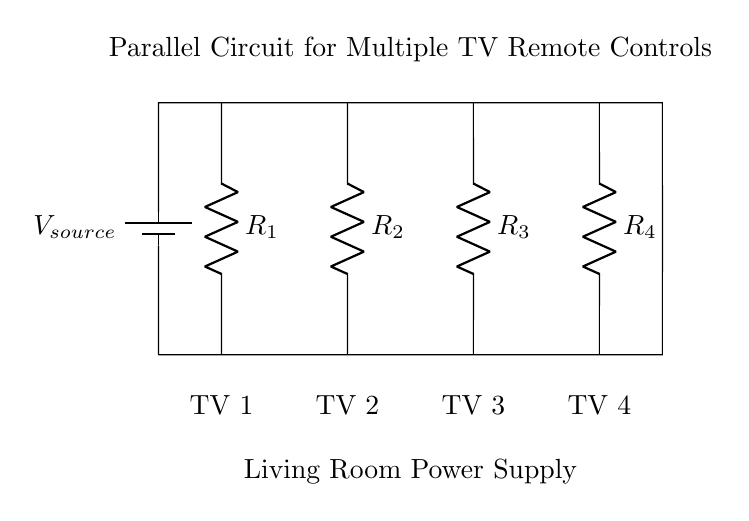What is the source voltage of the circuit? The source voltage is indicated as V source in the circuit diagram, representing the power supply voltage for all components connected in parallel.
Answer: V source How many resistors are present in this circuit? The circuit diagram shows four resistors labeled R1, R2, R3, and R4, indicating that there are four resistors in total.
Answer: 4 Which TV corresponds to R2? R2 connects to the second TV labeled in the circuit diagram as TV 2, which indicates that it corresponds to the second remote control in the living room setup.
Answer: TV 2 What type of circuit is illustrated in the diagram? The diagram depicts a parallel circuit as evidenced by the arrangement of the branches where each resistor (TV remote) is connected individually to the same voltage source without affecting the others.
Answer: Parallel How is the current distributed in the circuit? In a parallel circuit, the total current from the source splits among the various branches; thus, each branch can carry different currents depending on the resistance values, allowing each TV to operate independently.
Answer: Splits among branches What happens to the voltage across each TV remote? In a parallel circuit, each remote control (resistor) experiences the same voltage as the source; thus, the voltage across each TV remote is equal to V source, ensuring uniform operation across all TVs.
Answer: Equal to V source 